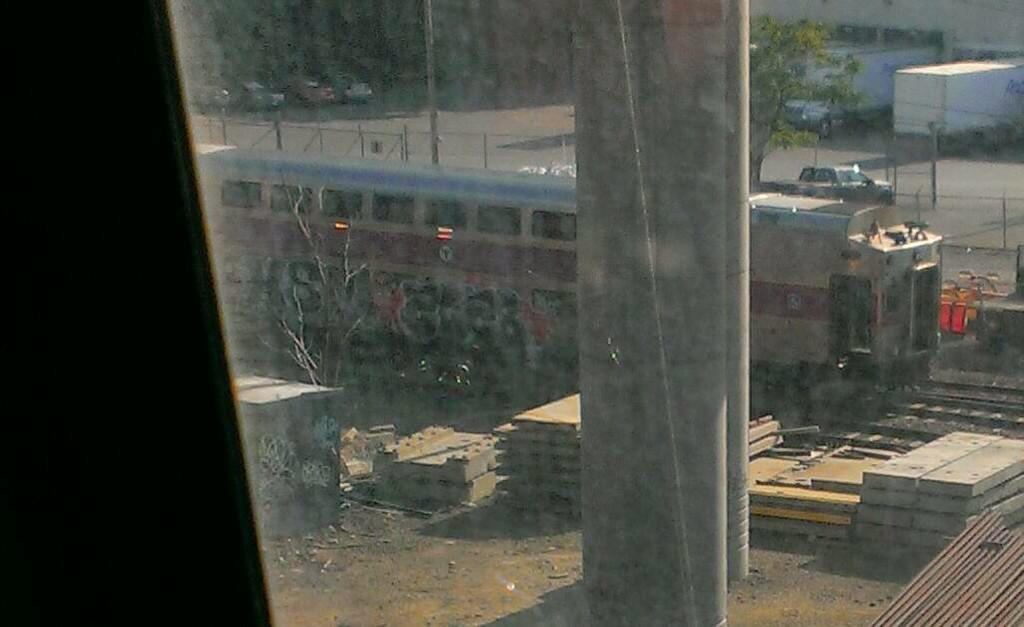What is the main subject of the image? There is a train in the image. What structures can be seen in the image? There are poles and pillars in the image. What type of natural elements are present in the image? There are trees in the image. What else can be seen moving in the image? There are vehicles in the image. What type of barrier is visible in the image? There is a fence in the image. What other objects are present on the ground in the image? There are other objects on the ground in the image. What type of snail can be seen crawling on the train in the image? There is no snail present on the train in the image. What is the texture of the chin of the person driving the train in the image? There is no person driving the train in the image, and therefore no chin to describe. 